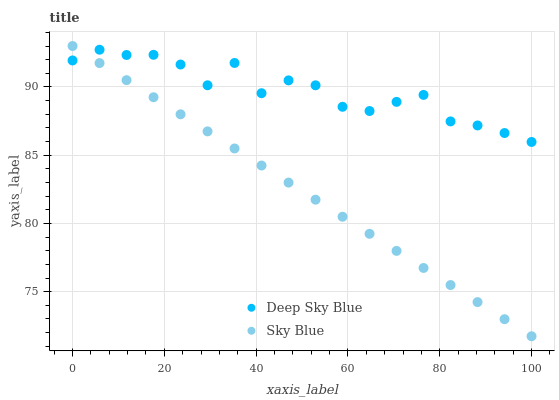Does Sky Blue have the minimum area under the curve?
Answer yes or no. Yes. Does Deep Sky Blue have the maximum area under the curve?
Answer yes or no. Yes. Does Deep Sky Blue have the minimum area under the curve?
Answer yes or no. No. Is Sky Blue the smoothest?
Answer yes or no. Yes. Is Deep Sky Blue the roughest?
Answer yes or no. Yes. Is Deep Sky Blue the smoothest?
Answer yes or no. No. Does Sky Blue have the lowest value?
Answer yes or no. Yes. Does Deep Sky Blue have the lowest value?
Answer yes or no. No. Does Sky Blue have the highest value?
Answer yes or no. Yes. Does Deep Sky Blue have the highest value?
Answer yes or no. No. Does Deep Sky Blue intersect Sky Blue?
Answer yes or no. Yes. Is Deep Sky Blue less than Sky Blue?
Answer yes or no. No. Is Deep Sky Blue greater than Sky Blue?
Answer yes or no. No. 